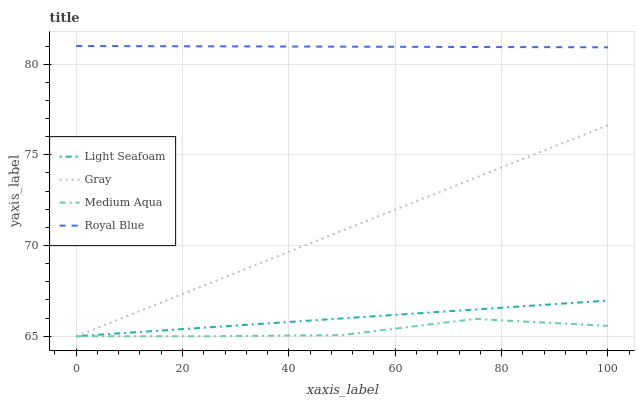Does Medium Aqua have the minimum area under the curve?
Answer yes or no. Yes. Does Royal Blue have the maximum area under the curve?
Answer yes or no. Yes. Does Light Seafoam have the minimum area under the curve?
Answer yes or no. No. Does Light Seafoam have the maximum area under the curve?
Answer yes or no. No. Is Gray the smoothest?
Answer yes or no. Yes. Is Medium Aqua the roughest?
Answer yes or no. Yes. Is Medium Aqua the smoothest?
Answer yes or no. No. Is Light Seafoam the roughest?
Answer yes or no. No. Does Gray have the lowest value?
Answer yes or no. Yes. Does Royal Blue have the lowest value?
Answer yes or no. No. Does Royal Blue have the highest value?
Answer yes or no. Yes. Does Light Seafoam have the highest value?
Answer yes or no. No. Is Medium Aqua less than Royal Blue?
Answer yes or no. Yes. Is Royal Blue greater than Medium Aqua?
Answer yes or no. Yes. Does Gray intersect Medium Aqua?
Answer yes or no. Yes. Is Gray less than Medium Aqua?
Answer yes or no. No. Is Gray greater than Medium Aqua?
Answer yes or no. No. Does Medium Aqua intersect Royal Blue?
Answer yes or no. No. 